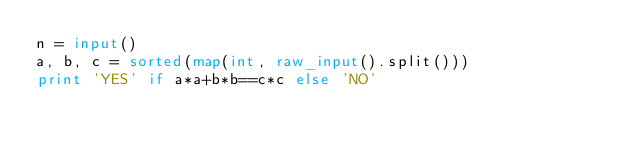Convert code to text. <code><loc_0><loc_0><loc_500><loc_500><_Python_>n = input()
a, b, c = sorted(map(int, raw_input().split()))
print 'YES' if a*a+b*b==c*c else 'NO'</code> 